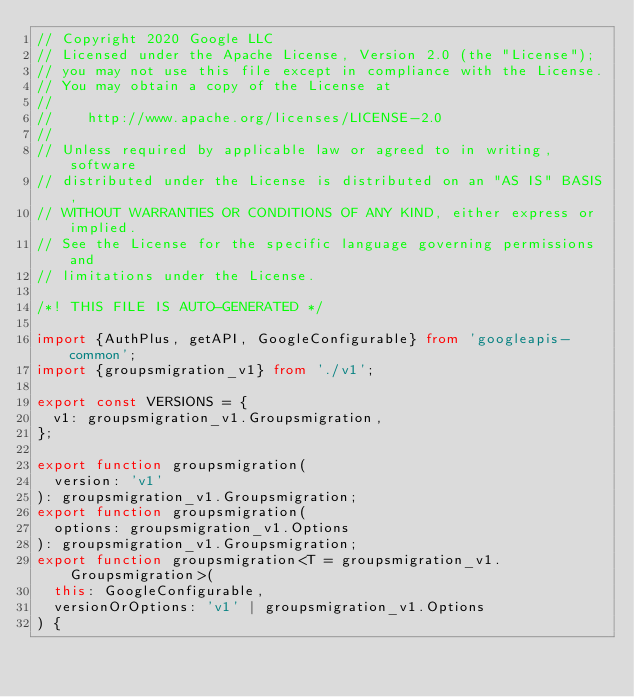Convert code to text. <code><loc_0><loc_0><loc_500><loc_500><_TypeScript_>// Copyright 2020 Google LLC
// Licensed under the Apache License, Version 2.0 (the "License");
// you may not use this file except in compliance with the License.
// You may obtain a copy of the License at
//
//    http://www.apache.org/licenses/LICENSE-2.0
//
// Unless required by applicable law or agreed to in writing, software
// distributed under the License is distributed on an "AS IS" BASIS,
// WITHOUT WARRANTIES OR CONDITIONS OF ANY KIND, either express or implied.
// See the License for the specific language governing permissions and
// limitations under the License.

/*! THIS FILE IS AUTO-GENERATED */

import {AuthPlus, getAPI, GoogleConfigurable} from 'googleapis-common';
import {groupsmigration_v1} from './v1';

export const VERSIONS = {
  v1: groupsmigration_v1.Groupsmigration,
};

export function groupsmigration(
  version: 'v1'
): groupsmigration_v1.Groupsmigration;
export function groupsmigration(
  options: groupsmigration_v1.Options
): groupsmigration_v1.Groupsmigration;
export function groupsmigration<T = groupsmigration_v1.Groupsmigration>(
  this: GoogleConfigurable,
  versionOrOptions: 'v1' | groupsmigration_v1.Options
) {</code> 